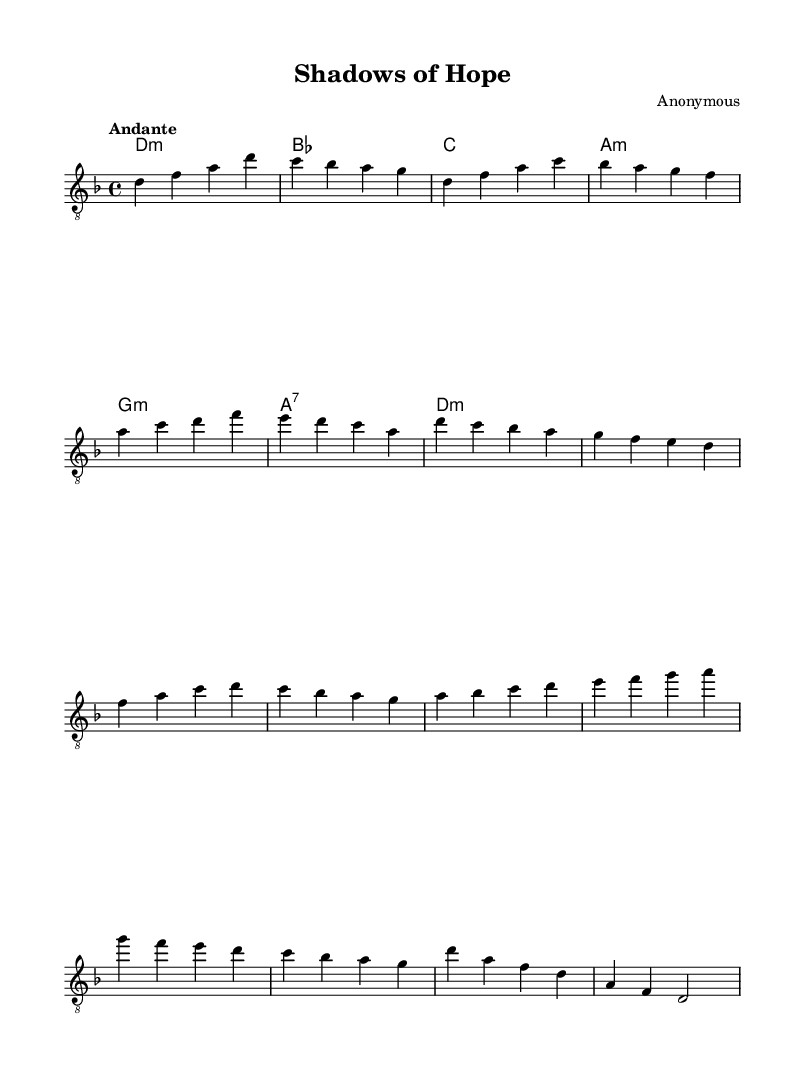What is the key signature of this music? The key signature is indicated at the beginning of the staff. It shows that there is one flat, which corresponds to the key of D minor.
Answer: D minor What is the time signature of the piece? The time signature is found at the beginning of the music, shown as 4/4. This means there are four beats per measure.
Answer: 4/4 What is the tempo marking for this piece? The tempo marking is given right after the time signature and it indicates the speed of the piece. It reads "Andante", which suggests a moderate walking pace.
Answer: Andante What are the first two notes of the melody? The first two notes of the melody can be seen in the Intro section at the beginning. They are D and F in ascending order.
Answer: D, F How many measures are in the Chorus section? To find the number of measures in the Chorus, we look at that section specifically marked as the Chorus and count the measures. There are 4 measures in this section.
Answer: 4 What harmonies accompany the Bridge section? The harmonies are indicated alongside the melody. In the Bridge section, the harmonies match the chords indicated: A, B-flat, C, D, E, F, G, A.
Answer: A, B-flat, C, D, E, F, G What is the last note of the Outro? The last note of the Outro can be located at the end of the last measure, which concludes on D on the first line of the staff, as shown in the music.
Answer: D 